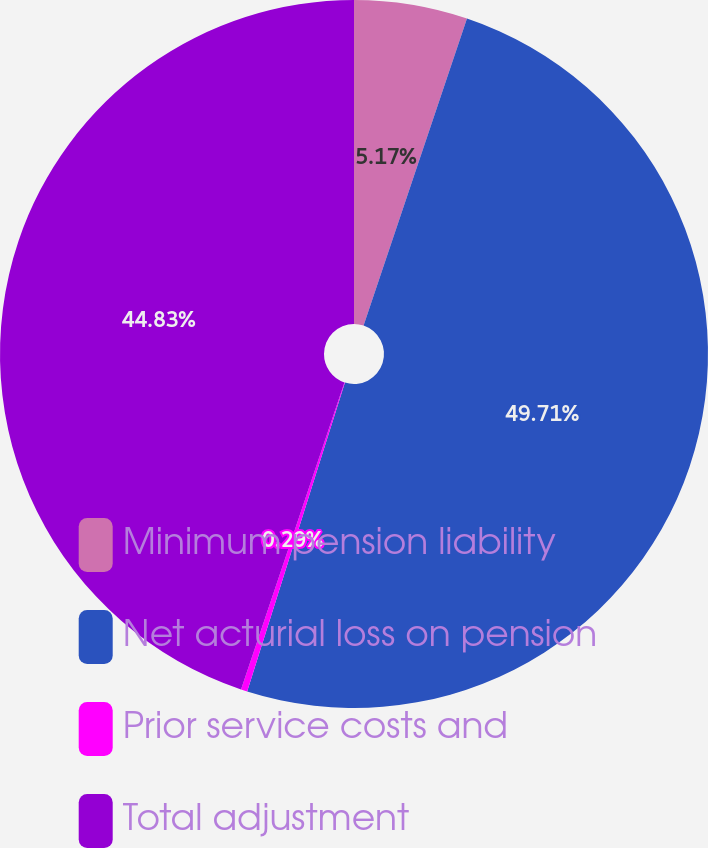Convert chart to OTSL. <chart><loc_0><loc_0><loc_500><loc_500><pie_chart><fcel>Minimum pension liability<fcel>Net acturial loss on pension<fcel>Prior service costs and<fcel>Total adjustment<nl><fcel>5.17%<fcel>49.71%<fcel>0.29%<fcel>44.83%<nl></chart> 